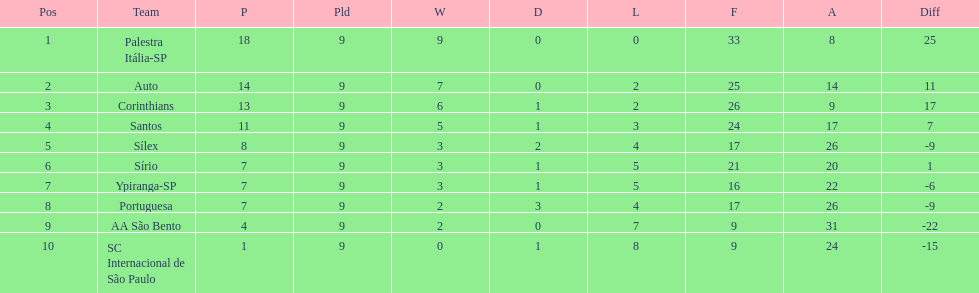How many teams had more points than silex? 4. 